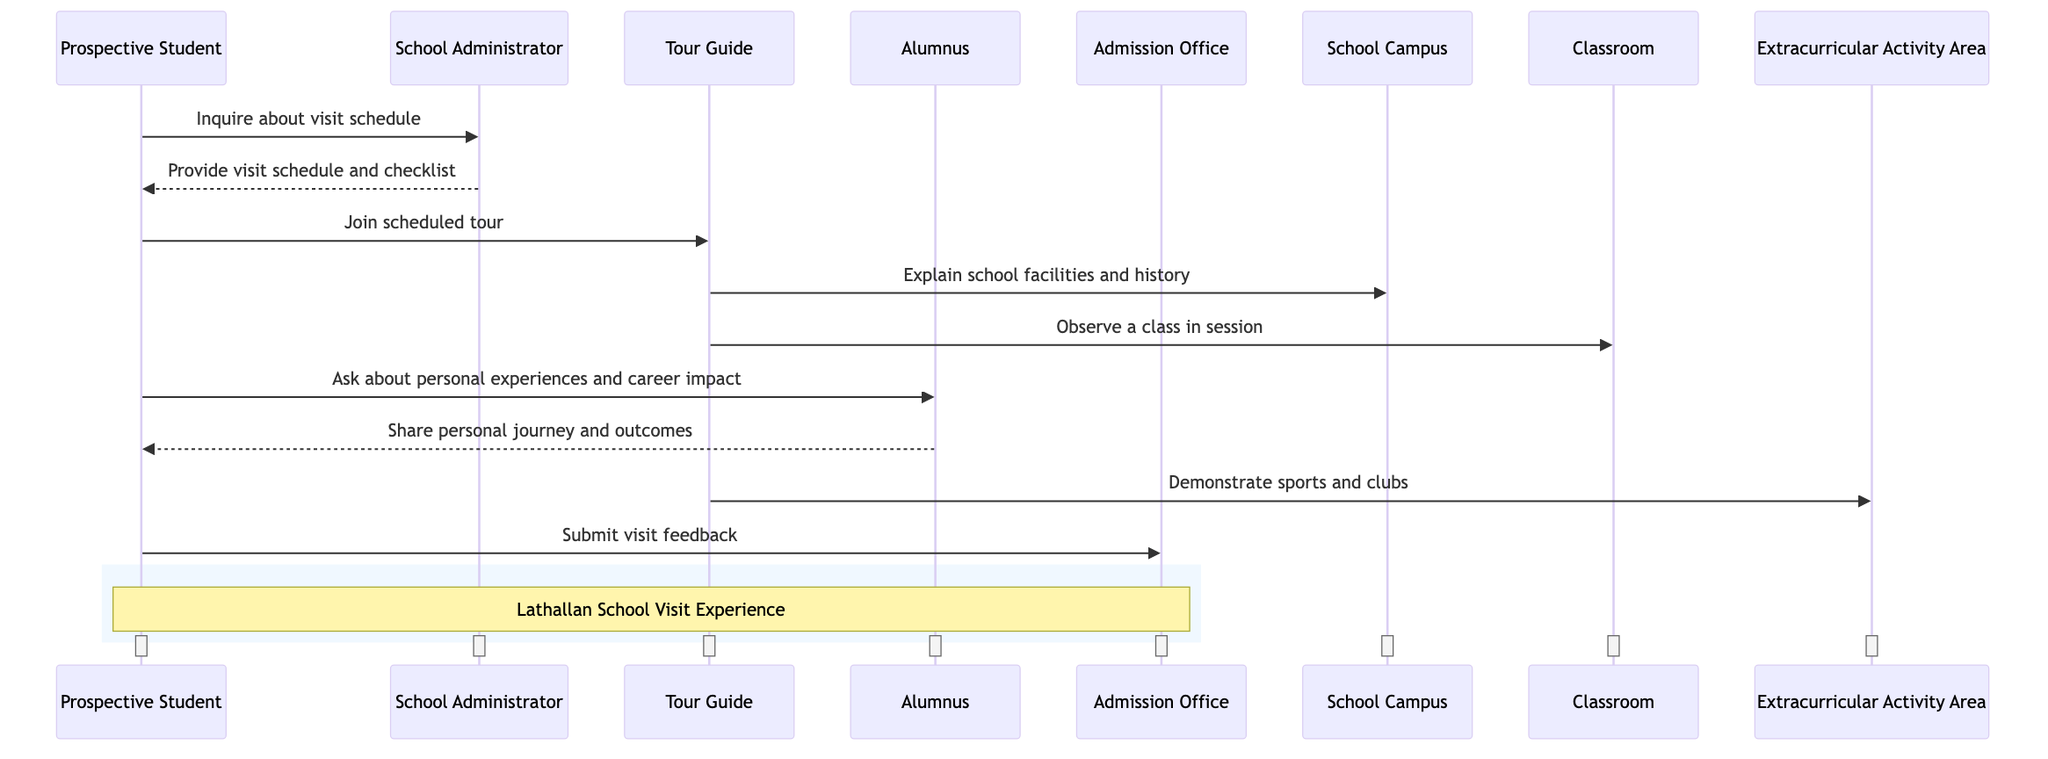What is the first message in the sequence? The first message comes from the "Prospective Student" to the "School Administrator," asking about the visit schedule.
Answer: Inquire about visit schedule How many participants are involved in this sequence diagram? The diagram lists four primary actors: "Prospective Student," "Alumnus," "School Administrator," and "Tour Guide."
Answer: Four Which object does the Tour Guide explain? The Tour Guide explains the "School Campus," detailing its facilities and history as part of the tour.
Answer: School Campus What was the Prospective Student's last action in the sequence? The last recorded action of the Prospective Student is submitting feedback to the "Admission Office."
Answer: Submit visit feedback Which participant shares their personal journey with the Prospective Student? The "Alumnus" shares their personal journey and outcomes with the Prospective Student in response to their inquiry.
Answer: Alumnus What are the total number of objects in the diagram? The diagram contains four distinct objects, including the "Admission Office," "School Campus," "Classroom," and "Extracurricular Activity Area."
Answer: Four What is the significance of the note shown in the diagram? The note indicates that the sequence relates to the "Lathallan School Visit Experience," summarizing the overall context of the diagram.
Answer: Lathallan School Visit Experience What type of activities does the Tour Guide show in the Extracurricular Activity Area? The Tour Guide demonstrates various sports and clubs available in the Extracurricular Activity Area as part of the tour experience.
Answer: Sports and clubs 